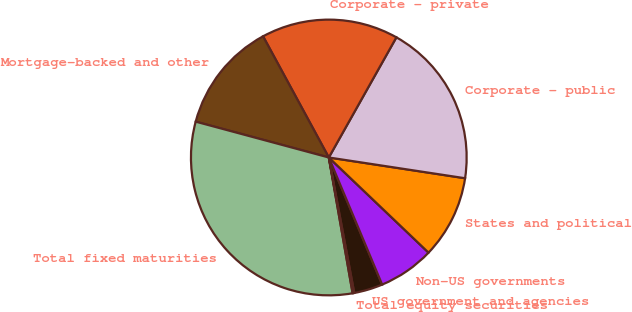<chart> <loc_0><loc_0><loc_500><loc_500><pie_chart><fcel>US government and agencies<fcel>Non-US governments<fcel>States and political<fcel>Corporate - public<fcel>Corporate - private<fcel>Mortgage-backed and other<fcel>Total fixed maturities<fcel>Total equity securities<nl><fcel>3.37%<fcel>6.55%<fcel>9.72%<fcel>19.25%<fcel>16.07%<fcel>12.9%<fcel>31.95%<fcel>0.19%<nl></chart> 